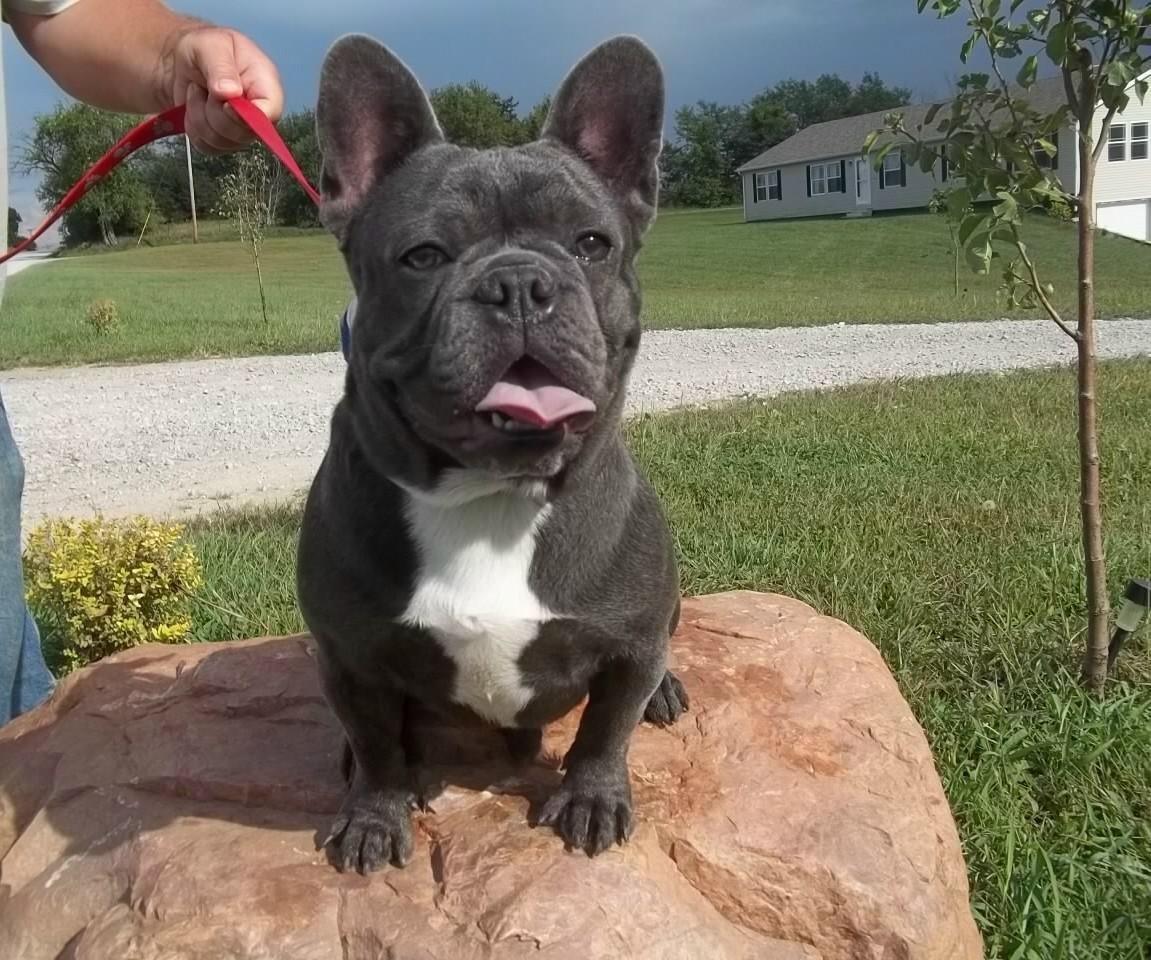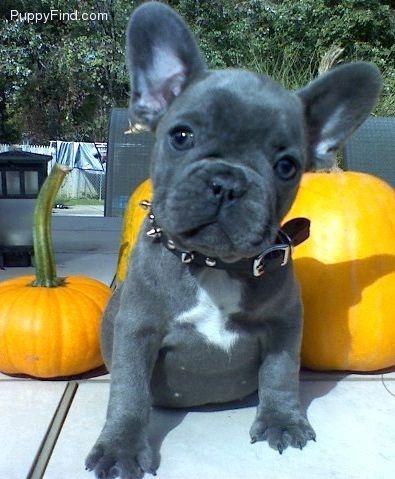The first image is the image on the left, the second image is the image on the right. Examine the images to the left and right. Is the description "A dark dog is wearing a blue vest and is inside of a shopping cart." accurate? Answer yes or no. No. The first image is the image on the left, the second image is the image on the right. For the images shown, is this caption "Two puppies are inside a shopping cart." true? Answer yes or no. No. 